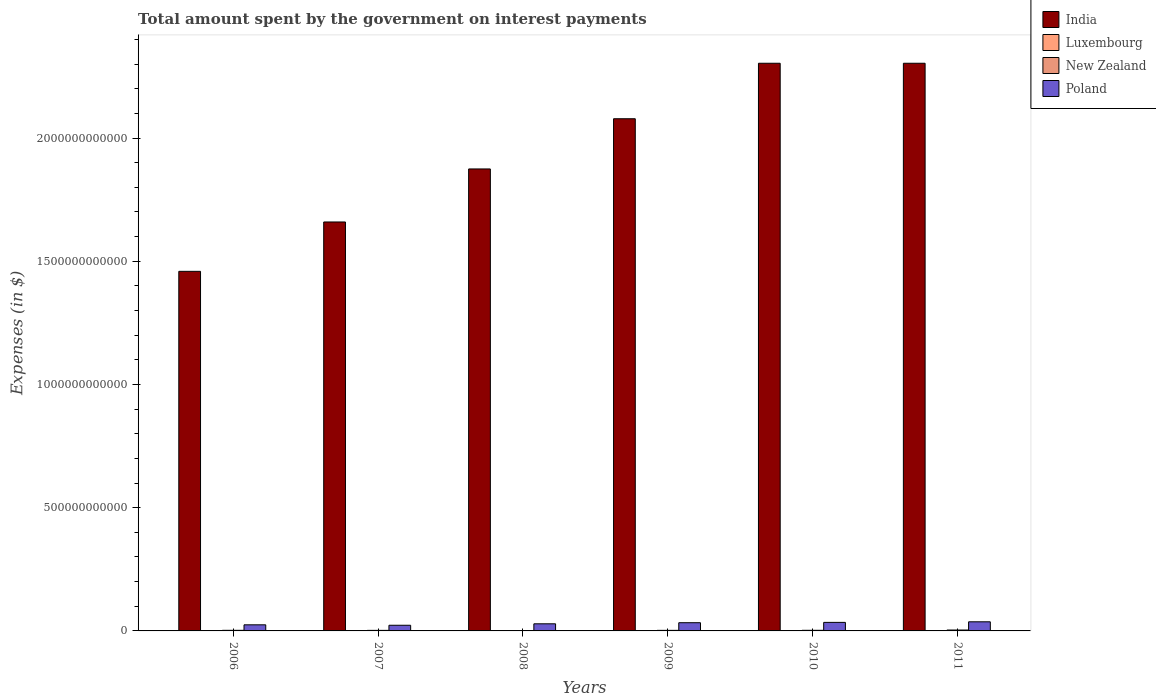How many groups of bars are there?
Provide a short and direct response. 6. How many bars are there on the 5th tick from the left?
Your response must be concise. 4. How many bars are there on the 1st tick from the right?
Your answer should be compact. 4. What is the amount spent on interest payments by the government in India in 2007?
Give a very brief answer. 1.66e+12. Across all years, what is the maximum amount spent on interest payments by the government in Poland?
Offer a terse response. 3.70e+1. Across all years, what is the minimum amount spent on interest payments by the government in India?
Your answer should be very brief. 1.46e+12. In which year was the amount spent on interest payments by the government in Poland maximum?
Keep it short and to the point. 2011. What is the total amount spent on interest payments by the government in Poland in the graph?
Offer a terse response. 1.82e+11. What is the difference between the amount spent on interest payments by the government in Poland in 2006 and that in 2009?
Your response must be concise. -8.59e+09. What is the difference between the amount spent on interest payments by the government in India in 2011 and the amount spent on interest payments by the government in New Zealand in 2007?
Your answer should be very brief. 2.30e+12. What is the average amount spent on interest payments by the government in Poland per year?
Offer a terse response. 3.03e+1. In the year 2011, what is the difference between the amount spent on interest payments by the government in Luxembourg and amount spent on interest payments by the government in India?
Keep it short and to the point. -2.30e+12. In how many years, is the amount spent on interest payments by the government in India greater than 2200000000000 $?
Your response must be concise. 2. What is the ratio of the amount spent on interest payments by the government in Luxembourg in 2009 to that in 2011?
Offer a terse response. 0.65. Is the amount spent on interest payments by the government in Poland in 2010 less than that in 2011?
Ensure brevity in your answer.  Yes. What is the difference between the highest and the lowest amount spent on interest payments by the government in Luxembourg?
Your response must be concise. 1.47e+08. In how many years, is the amount spent on interest payments by the government in Poland greater than the average amount spent on interest payments by the government in Poland taken over all years?
Keep it short and to the point. 3. Is it the case that in every year, the sum of the amount spent on interest payments by the government in Luxembourg and amount spent on interest payments by the government in Poland is greater than the sum of amount spent on interest payments by the government in New Zealand and amount spent on interest payments by the government in India?
Provide a short and direct response. No. What does the 2nd bar from the left in 2006 represents?
Offer a terse response. Luxembourg. What does the 4th bar from the right in 2009 represents?
Your response must be concise. India. Is it the case that in every year, the sum of the amount spent on interest payments by the government in Poland and amount spent on interest payments by the government in Luxembourg is greater than the amount spent on interest payments by the government in India?
Provide a succinct answer. No. How many bars are there?
Your answer should be very brief. 24. Are all the bars in the graph horizontal?
Offer a terse response. No. How many years are there in the graph?
Provide a succinct answer. 6. What is the difference between two consecutive major ticks on the Y-axis?
Your response must be concise. 5.00e+11. Are the values on the major ticks of Y-axis written in scientific E-notation?
Offer a terse response. No. Does the graph contain grids?
Provide a succinct answer. No. How are the legend labels stacked?
Give a very brief answer. Vertical. What is the title of the graph?
Your response must be concise. Total amount spent by the government on interest payments. What is the label or title of the Y-axis?
Your response must be concise. Expenses (in $). What is the Expenses (in $) of India in 2006?
Keep it short and to the point. 1.46e+12. What is the Expenses (in $) of Luxembourg in 2006?
Give a very brief answer. 3.89e+07. What is the Expenses (in $) of New Zealand in 2006?
Ensure brevity in your answer.  2.46e+09. What is the Expenses (in $) of Poland in 2006?
Keep it short and to the point. 2.47e+1. What is the Expenses (in $) in India in 2007?
Provide a succinct answer. 1.66e+12. What is the Expenses (in $) of Luxembourg in 2007?
Provide a short and direct response. 5.74e+07. What is the Expenses (in $) of New Zealand in 2007?
Give a very brief answer. 2.25e+09. What is the Expenses (in $) in Poland in 2007?
Your response must be concise. 2.30e+1. What is the Expenses (in $) of India in 2008?
Provide a short and direct response. 1.87e+12. What is the Expenses (in $) in Luxembourg in 2008?
Your answer should be compact. 8.89e+07. What is the Expenses (in $) of New Zealand in 2008?
Your response must be concise. 1.34e+09. What is the Expenses (in $) of Poland in 2008?
Offer a terse response. 2.89e+1. What is the Expenses (in $) of India in 2009?
Give a very brief answer. 2.08e+12. What is the Expenses (in $) of Luxembourg in 2009?
Offer a very short reply. 1.20e+08. What is the Expenses (in $) in New Zealand in 2009?
Give a very brief answer. 2.30e+09. What is the Expenses (in $) of Poland in 2009?
Ensure brevity in your answer.  3.33e+1. What is the Expenses (in $) of India in 2010?
Your answer should be very brief. 2.30e+12. What is the Expenses (in $) of Luxembourg in 2010?
Provide a short and direct response. 1.51e+08. What is the Expenses (in $) of New Zealand in 2010?
Make the answer very short. 2.52e+09. What is the Expenses (in $) in Poland in 2010?
Your answer should be compact. 3.47e+1. What is the Expenses (in $) of India in 2011?
Give a very brief answer. 2.30e+12. What is the Expenses (in $) in Luxembourg in 2011?
Your answer should be very brief. 1.86e+08. What is the Expenses (in $) in New Zealand in 2011?
Ensure brevity in your answer.  3.66e+09. What is the Expenses (in $) of Poland in 2011?
Your response must be concise. 3.70e+1. Across all years, what is the maximum Expenses (in $) of India?
Keep it short and to the point. 2.30e+12. Across all years, what is the maximum Expenses (in $) in Luxembourg?
Give a very brief answer. 1.86e+08. Across all years, what is the maximum Expenses (in $) in New Zealand?
Provide a succinct answer. 3.66e+09. Across all years, what is the maximum Expenses (in $) in Poland?
Offer a very short reply. 3.70e+1. Across all years, what is the minimum Expenses (in $) in India?
Provide a short and direct response. 1.46e+12. Across all years, what is the minimum Expenses (in $) of Luxembourg?
Provide a short and direct response. 3.89e+07. Across all years, what is the minimum Expenses (in $) in New Zealand?
Offer a very short reply. 1.34e+09. Across all years, what is the minimum Expenses (in $) of Poland?
Ensure brevity in your answer.  2.30e+1. What is the total Expenses (in $) of India in the graph?
Give a very brief answer. 1.17e+13. What is the total Expenses (in $) of Luxembourg in the graph?
Ensure brevity in your answer.  6.42e+08. What is the total Expenses (in $) in New Zealand in the graph?
Give a very brief answer. 1.45e+1. What is the total Expenses (in $) in Poland in the graph?
Ensure brevity in your answer.  1.82e+11. What is the difference between the Expenses (in $) in India in 2006 and that in 2007?
Give a very brief answer. -2.00e+11. What is the difference between the Expenses (in $) in Luxembourg in 2006 and that in 2007?
Provide a succinct answer. -1.85e+07. What is the difference between the Expenses (in $) in New Zealand in 2006 and that in 2007?
Your answer should be very brief. 2.02e+08. What is the difference between the Expenses (in $) in Poland in 2006 and that in 2007?
Offer a terse response. 1.73e+09. What is the difference between the Expenses (in $) in India in 2006 and that in 2008?
Your answer should be compact. -4.16e+11. What is the difference between the Expenses (in $) in Luxembourg in 2006 and that in 2008?
Your answer should be very brief. -4.99e+07. What is the difference between the Expenses (in $) in New Zealand in 2006 and that in 2008?
Ensure brevity in your answer.  1.12e+09. What is the difference between the Expenses (in $) in Poland in 2006 and that in 2008?
Provide a succinct answer. -4.13e+09. What is the difference between the Expenses (in $) in India in 2006 and that in 2009?
Make the answer very short. -6.19e+11. What is the difference between the Expenses (in $) of Luxembourg in 2006 and that in 2009?
Ensure brevity in your answer.  -8.14e+07. What is the difference between the Expenses (in $) of New Zealand in 2006 and that in 2009?
Your response must be concise. 1.59e+08. What is the difference between the Expenses (in $) in Poland in 2006 and that in 2009?
Provide a succinct answer. -8.59e+09. What is the difference between the Expenses (in $) of India in 2006 and that in 2010?
Your answer should be very brief. -8.44e+11. What is the difference between the Expenses (in $) in Luxembourg in 2006 and that in 2010?
Provide a succinct answer. -1.12e+08. What is the difference between the Expenses (in $) in New Zealand in 2006 and that in 2010?
Provide a succinct answer. -6.60e+07. What is the difference between the Expenses (in $) in Poland in 2006 and that in 2010?
Give a very brief answer. -9.93e+09. What is the difference between the Expenses (in $) in India in 2006 and that in 2011?
Provide a short and direct response. -8.44e+11. What is the difference between the Expenses (in $) of Luxembourg in 2006 and that in 2011?
Give a very brief answer. -1.47e+08. What is the difference between the Expenses (in $) of New Zealand in 2006 and that in 2011?
Provide a succinct answer. -1.20e+09. What is the difference between the Expenses (in $) in Poland in 2006 and that in 2011?
Give a very brief answer. -1.22e+1. What is the difference between the Expenses (in $) of India in 2007 and that in 2008?
Keep it short and to the point. -2.15e+11. What is the difference between the Expenses (in $) in Luxembourg in 2007 and that in 2008?
Provide a short and direct response. -3.15e+07. What is the difference between the Expenses (in $) in New Zealand in 2007 and that in 2008?
Your answer should be compact. 9.17e+08. What is the difference between the Expenses (in $) of Poland in 2007 and that in 2008?
Offer a very short reply. -5.86e+09. What is the difference between the Expenses (in $) in India in 2007 and that in 2009?
Offer a terse response. -4.19e+11. What is the difference between the Expenses (in $) in Luxembourg in 2007 and that in 2009?
Your response must be concise. -6.29e+07. What is the difference between the Expenses (in $) in New Zealand in 2007 and that in 2009?
Provide a succinct answer. -4.27e+07. What is the difference between the Expenses (in $) of Poland in 2007 and that in 2009?
Offer a very short reply. -1.03e+1. What is the difference between the Expenses (in $) in India in 2007 and that in 2010?
Ensure brevity in your answer.  -6.44e+11. What is the difference between the Expenses (in $) of Luxembourg in 2007 and that in 2010?
Ensure brevity in your answer.  -9.34e+07. What is the difference between the Expenses (in $) of New Zealand in 2007 and that in 2010?
Keep it short and to the point. -2.68e+08. What is the difference between the Expenses (in $) in Poland in 2007 and that in 2010?
Your response must be concise. -1.17e+1. What is the difference between the Expenses (in $) of India in 2007 and that in 2011?
Your answer should be compact. -6.44e+11. What is the difference between the Expenses (in $) of Luxembourg in 2007 and that in 2011?
Your answer should be very brief. -1.28e+08. What is the difference between the Expenses (in $) of New Zealand in 2007 and that in 2011?
Keep it short and to the point. -1.41e+09. What is the difference between the Expenses (in $) of Poland in 2007 and that in 2011?
Your answer should be compact. -1.40e+1. What is the difference between the Expenses (in $) of India in 2008 and that in 2009?
Provide a succinct answer. -2.04e+11. What is the difference between the Expenses (in $) in Luxembourg in 2008 and that in 2009?
Offer a very short reply. -3.14e+07. What is the difference between the Expenses (in $) in New Zealand in 2008 and that in 2009?
Ensure brevity in your answer.  -9.60e+08. What is the difference between the Expenses (in $) in Poland in 2008 and that in 2009?
Offer a terse response. -4.46e+09. What is the difference between the Expenses (in $) of India in 2008 and that in 2010?
Ensure brevity in your answer.  -4.29e+11. What is the difference between the Expenses (in $) in Luxembourg in 2008 and that in 2010?
Offer a very short reply. -6.20e+07. What is the difference between the Expenses (in $) in New Zealand in 2008 and that in 2010?
Give a very brief answer. -1.18e+09. What is the difference between the Expenses (in $) in Poland in 2008 and that in 2010?
Your answer should be very brief. -5.80e+09. What is the difference between the Expenses (in $) of India in 2008 and that in 2011?
Ensure brevity in your answer.  -4.29e+11. What is the difference between the Expenses (in $) in Luxembourg in 2008 and that in 2011?
Offer a very short reply. -9.67e+07. What is the difference between the Expenses (in $) in New Zealand in 2008 and that in 2011?
Your answer should be very brief. -2.32e+09. What is the difference between the Expenses (in $) in Poland in 2008 and that in 2011?
Give a very brief answer. -8.12e+09. What is the difference between the Expenses (in $) in India in 2009 and that in 2010?
Your response must be concise. -2.25e+11. What is the difference between the Expenses (in $) in Luxembourg in 2009 and that in 2010?
Offer a very short reply. -3.06e+07. What is the difference between the Expenses (in $) of New Zealand in 2009 and that in 2010?
Make the answer very short. -2.25e+08. What is the difference between the Expenses (in $) in Poland in 2009 and that in 2010?
Keep it short and to the point. -1.34e+09. What is the difference between the Expenses (in $) in India in 2009 and that in 2011?
Give a very brief answer. -2.25e+11. What is the difference between the Expenses (in $) in Luxembourg in 2009 and that in 2011?
Your answer should be compact. -6.53e+07. What is the difference between the Expenses (in $) in New Zealand in 2009 and that in 2011?
Make the answer very short. -1.36e+09. What is the difference between the Expenses (in $) of Poland in 2009 and that in 2011?
Provide a short and direct response. -3.66e+09. What is the difference between the Expenses (in $) of India in 2010 and that in 2011?
Provide a succinct answer. 0. What is the difference between the Expenses (in $) in Luxembourg in 2010 and that in 2011?
Ensure brevity in your answer.  -3.47e+07. What is the difference between the Expenses (in $) of New Zealand in 2010 and that in 2011?
Your response must be concise. -1.14e+09. What is the difference between the Expenses (in $) of Poland in 2010 and that in 2011?
Provide a short and direct response. -2.32e+09. What is the difference between the Expenses (in $) in India in 2006 and the Expenses (in $) in Luxembourg in 2007?
Offer a terse response. 1.46e+12. What is the difference between the Expenses (in $) of India in 2006 and the Expenses (in $) of New Zealand in 2007?
Give a very brief answer. 1.46e+12. What is the difference between the Expenses (in $) of India in 2006 and the Expenses (in $) of Poland in 2007?
Make the answer very short. 1.44e+12. What is the difference between the Expenses (in $) of Luxembourg in 2006 and the Expenses (in $) of New Zealand in 2007?
Keep it short and to the point. -2.22e+09. What is the difference between the Expenses (in $) in Luxembourg in 2006 and the Expenses (in $) in Poland in 2007?
Make the answer very short. -2.30e+1. What is the difference between the Expenses (in $) in New Zealand in 2006 and the Expenses (in $) in Poland in 2007?
Your answer should be very brief. -2.05e+1. What is the difference between the Expenses (in $) of India in 2006 and the Expenses (in $) of Luxembourg in 2008?
Ensure brevity in your answer.  1.46e+12. What is the difference between the Expenses (in $) in India in 2006 and the Expenses (in $) in New Zealand in 2008?
Provide a succinct answer. 1.46e+12. What is the difference between the Expenses (in $) in India in 2006 and the Expenses (in $) in Poland in 2008?
Your answer should be compact. 1.43e+12. What is the difference between the Expenses (in $) of Luxembourg in 2006 and the Expenses (in $) of New Zealand in 2008?
Make the answer very short. -1.30e+09. What is the difference between the Expenses (in $) of Luxembourg in 2006 and the Expenses (in $) of Poland in 2008?
Your response must be concise. -2.88e+1. What is the difference between the Expenses (in $) in New Zealand in 2006 and the Expenses (in $) in Poland in 2008?
Offer a terse response. -2.64e+1. What is the difference between the Expenses (in $) of India in 2006 and the Expenses (in $) of Luxembourg in 2009?
Offer a very short reply. 1.46e+12. What is the difference between the Expenses (in $) in India in 2006 and the Expenses (in $) in New Zealand in 2009?
Provide a succinct answer. 1.46e+12. What is the difference between the Expenses (in $) in India in 2006 and the Expenses (in $) in Poland in 2009?
Ensure brevity in your answer.  1.43e+12. What is the difference between the Expenses (in $) of Luxembourg in 2006 and the Expenses (in $) of New Zealand in 2009?
Your answer should be compact. -2.26e+09. What is the difference between the Expenses (in $) of Luxembourg in 2006 and the Expenses (in $) of Poland in 2009?
Offer a very short reply. -3.33e+1. What is the difference between the Expenses (in $) in New Zealand in 2006 and the Expenses (in $) in Poland in 2009?
Offer a terse response. -3.09e+1. What is the difference between the Expenses (in $) in India in 2006 and the Expenses (in $) in Luxembourg in 2010?
Give a very brief answer. 1.46e+12. What is the difference between the Expenses (in $) in India in 2006 and the Expenses (in $) in New Zealand in 2010?
Provide a succinct answer. 1.46e+12. What is the difference between the Expenses (in $) of India in 2006 and the Expenses (in $) of Poland in 2010?
Give a very brief answer. 1.42e+12. What is the difference between the Expenses (in $) of Luxembourg in 2006 and the Expenses (in $) of New Zealand in 2010?
Provide a succinct answer. -2.48e+09. What is the difference between the Expenses (in $) in Luxembourg in 2006 and the Expenses (in $) in Poland in 2010?
Your answer should be very brief. -3.46e+1. What is the difference between the Expenses (in $) of New Zealand in 2006 and the Expenses (in $) of Poland in 2010?
Offer a terse response. -3.22e+1. What is the difference between the Expenses (in $) in India in 2006 and the Expenses (in $) in Luxembourg in 2011?
Your answer should be compact. 1.46e+12. What is the difference between the Expenses (in $) in India in 2006 and the Expenses (in $) in New Zealand in 2011?
Your answer should be very brief. 1.46e+12. What is the difference between the Expenses (in $) of India in 2006 and the Expenses (in $) of Poland in 2011?
Ensure brevity in your answer.  1.42e+12. What is the difference between the Expenses (in $) of Luxembourg in 2006 and the Expenses (in $) of New Zealand in 2011?
Offer a terse response. -3.62e+09. What is the difference between the Expenses (in $) in Luxembourg in 2006 and the Expenses (in $) in Poland in 2011?
Your answer should be compact. -3.69e+1. What is the difference between the Expenses (in $) in New Zealand in 2006 and the Expenses (in $) in Poland in 2011?
Give a very brief answer. -3.45e+1. What is the difference between the Expenses (in $) in India in 2007 and the Expenses (in $) in Luxembourg in 2008?
Your answer should be compact. 1.66e+12. What is the difference between the Expenses (in $) in India in 2007 and the Expenses (in $) in New Zealand in 2008?
Offer a very short reply. 1.66e+12. What is the difference between the Expenses (in $) in India in 2007 and the Expenses (in $) in Poland in 2008?
Keep it short and to the point. 1.63e+12. What is the difference between the Expenses (in $) of Luxembourg in 2007 and the Expenses (in $) of New Zealand in 2008?
Offer a very short reply. -1.28e+09. What is the difference between the Expenses (in $) in Luxembourg in 2007 and the Expenses (in $) in Poland in 2008?
Keep it short and to the point. -2.88e+1. What is the difference between the Expenses (in $) of New Zealand in 2007 and the Expenses (in $) of Poland in 2008?
Keep it short and to the point. -2.66e+1. What is the difference between the Expenses (in $) in India in 2007 and the Expenses (in $) in Luxembourg in 2009?
Your answer should be compact. 1.66e+12. What is the difference between the Expenses (in $) of India in 2007 and the Expenses (in $) of New Zealand in 2009?
Make the answer very short. 1.66e+12. What is the difference between the Expenses (in $) of India in 2007 and the Expenses (in $) of Poland in 2009?
Provide a short and direct response. 1.63e+12. What is the difference between the Expenses (in $) of Luxembourg in 2007 and the Expenses (in $) of New Zealand in 2009?
Your answer should be compact. -2.24e+09. What is the difference between the Expenses (in $) in Luxembourg in 2007 and the Expenses (in $) in Poland in 2009?
Make the answer very short. -3.33e+1. What is the difference between the Expenses (in $) of New Zealand in 2007 and the Expenses (in $) of Poland in 2009?
Your answer should be compact. -3.11e+1. What is the difference between the Expenses (in $) of India in 2007 and the Expenses (in $) of Luxembourg in 2010?
Provide a short and direct response. 1.66e+12. What is the difference between the Expenses (in $) of India in 2007 and the Expenses (in $) of New Zealand in 2010?
Give a very brief answer. 1.66e+12. What is the difference between the Expenses (in $) of India in 2007 and the Expenses (in $) of Poland in 2010?
Offer a very short reply. 1.62e+12. What is the difference between the Expenses (in $) of Luxembourg in 2007 and the Expenses (in $) of New Zealand in 2010?
Your answer should be very brief. -2.46e+09. What is the difference between the Expenses (in $) of Luxembourg in 2007 and the Expenses (in $) of Poland in 2010?
Provide a short and direct response. -3.46e+1. What is the difference between the Expenses (in $) of New Zealand in 2007 and the Expenses (in $) of Poland in 2010?
Offer a terse response. -3.24e+1. What is the difference between the Expenses (in $) of India in 2007 and the Expenses (in $) of Luxembourg in 2011?
Provide a succinct answer. 1.66e+12. What is the difference between the Expenses (in $) in India in 2007 and the Expenses (in $) in New Zealand in 2011?
Give a very brief answer. 1.66e+12. What is the difference between the Expenses (in $) in India in 2007 and the Expenses (in $) in Poland in 2011?
Your response must be concise. 1.62e+12. What is the difference between the Expenses (in $) of Luxembourg in 2007 and the Expenses (in $) of New Zealand in 2011?
Provide a short and direct response. -3.60e+09. What is the difference between the Expenses (in $) in Luxembourg in 2007 and the Expenses (in $) in Poland in 2011?
Offer a terse response. -3.69e+1. What is the difference between the Expenses (in $) in New Zealand in 2007 and the Expenses (in $) in Poland in 2011?
Offer a terse response. -3.47e+1. What is the difference between the Expenses (in $) in India in 2008 and the Expenses (in $) in Luxembourg in 2009?
Keep it short and to the point. 1.87e+12. What is the difference between the Expenses (in $) of India in 2008 and the Expenses (in $) of New Zealand in 2009?
Your answer should be very brief. 1.87e+12. What is the difference between the Expenses (in $) in India in 2008 and the Expenses (in $) in Poland in 2009?
Give a very brief answer. 1.84e+12. What is the difference between the Expenses (in $) of Luxembourg in 2008 and the Expenses (in $) of New Zealand in 2009?
Keep it short and to the point. -2.21e+09. What is the difference between the Expenses (in $) in Luxembourg in 2008 and the Expenses (in $) in Poland in 2009?
Your answer should be compact. -3.32e+1. What is the difference between the Expenses (in $) of New Zealand in 2008 and the Expenses (in $) of Poland in 2009?
Make the answer very short. -3.20e+1. What is the difference between the Expenses (in $) in India in 2008 and the Expenses (in $) in Luxembourg in 2010?
Your answer should be compact. 1.87e+12. What is the difference between the Expenses (in $) of India in 2008 and the Expenses (in $) of New Zealand in 2010?
Your answer should be very brief. 1.87e+12. What is the difference between the Expenses (in $) of India in 2008 and the Expenses (in $) of Poland in 2010?
Offer a very short reply. 1.84e+12. What is the difference between the Expenses (in $) of Luxembourg in 2008 and the Expenses (in $) of New Zealand in 2010?
Your answer should be very brief. -2.43e+09. What is the difference between the Expenses (in $) of Luxembourg in 2008 and the Expenses (in $) of Poland in 2010?
Your answer should be compact. -3.46e+1. What is the difference between the Expenses (in $) of New Zealand in 2008 and the Expenses (in $) of Poland in 2010?
Your answer should be compact. -3.33e+1. What is the difference between the Expenses (in $) of India in 2008 and the Expenses (in $) of Luxembourg in 2011?
Provide a succinct answer. 1.87e+12. What is the difference between the Expenses (in $) of India in 2008 and the Expenses (in $) of New Zealand in 2011?
Your response must be concise. 1.87e+12. What is the difference between the Expenses (in $) in India in 2008 and the Expenses (in $) in Poland in 2011?
Provide a succinct answer. 1.84e+12. What is the difference between the Expenses (in $) in Luxembourg in 2008 and the Expenses (in $) in New Zealand in 2011?
Offer a terse response. -3.57e+09. What is the difference between the Expenses (in $) of Luxembourg in 2008 and the Expenses (in $) of Poland in 2011?
Provide a short and direct response. -3.69e+1. What is the difference between the Expenses (in $) in New Zealand in 2008 and the Expenses (in $) in Poland in 2011?
Provide a succinct answer. -3.56e+1. What is the difference between the Expenses (in $) in India in 2009 and the Expenses (in $) in Luxembourg in 2010?
Your answer should be compact. 2.08e+12. What is the difference between the Expenses (in $) in India in 2009 and the Expenses (in $) in New Zealand in 2010?
Offer a terse response. 2.08e+12. What is the difference between the Expenses (in $) in India in 2009 and the Expenses (in $) in Poland in 2010?
Provide a succinct answer. 2.04e+12. What is the difference between the Expenses (in $) of Luxembourg in 2009 and the Expenses (in $) of New Zealand in 2010?
Make the answer very short. -2.40e+09. What is the difference between the Expenses (in $) in Luxembourg in 2009 and the Expenses (in $) in Poland in 2010?
Provide a succinct answer. -3.45e+1. What is the difference between the Expenses (in $) of New Zealand in 2009 and the Expenses (in $) of Poland in 2010?
Your answer should be very brief. -3.24e+1. What is the difference between the Expenses (in $) of India in 2009 and the Expenses (in $) of Luxembourg in 2011?
Give a very brief answer. 2.08e+12. What is the difference between the Expenses (in $) of India in 2009 and the Expenses (in $) of New Zealand in 2011?
Provide a short and direct response. 2.07e+12. What is the difference between the Expenses (in $) of India in 2009 and the Expenses (in $) of Poland in 2011?
Provide a short and direct response. 2.04e+12. What is the difference between the Expenses (in $) of Luxembourg in 2009 and the Expenses (in $) of New Zealand in 2011?
Provide a succinct answer. -3.54e+09. What is the difference between the Expenses (in $) in Luxembourg in 2009 and the Expenses (in $) in Poland in 2011?
Your answer should be compact. -3.69e+1. What is the difference between the Expenses (in $) in New Zealand in 2009 and the Expenses (in $) in Poland in 2011?
Provide a short and direct response. -3.47e+1. What is the difference between the Expenses (in $) in India in 2010 and the Expenses (in $) in Luxembourg in 2011?
Your response must be concise. 2.30e+12. What is the difference between the Expenses (in $) in India in 2010 and the Expenses (in $) in New Zealand in 2011?
Keep it short and to the point. 2.30e+12. What is the difference between the Expenses (in $) in India in 2010 and the Expenses (in $) in Poland in 2011?
Provide a succinct answer. 2.27e+12. What is the difference between the Expenses (in $) in Luxembourg in 2010 and the Expenses (in $) in New Zealand in 2011?
Provide a short and direct response. -3.51e+09. What is the difference between the Expenses (in $) in Luxembourg in 2010 and the Expenses (in $) in Poland in 2011?
Your response must be concise. -3.68e+1. What is the difference between the Expenses (in $) in New Zealand in 2010 and the Expenses (in $) in Poland in 2011?
Your answer should be very brief. -3.45e+1. What is the average Expenses (in $) in India per year?
Offer a terse response. 1.95e+12. What is the average Expenses (in $) of Luxembourg per year?
Give a very brief answer. 1.07e+08. What is the average Expenses (in $) in New Zealand per year?
Make the answer very short. 2.42e+09. What is the average Expenses (in $) of Poland per year?
Provide a short and direct response. 3.03e+1. In the year 2006, what is the difference between the Expenses (in $) in India and Expenses (in $) in Luxembourg?
Your response must be concise. 1.46e+12. In the year 2006, what is the difference between the Expenses (in $) in India and Expenses (in $) in New Zealand?
Provide a short and direct response. 1.46e+12. In the year 2006, what is the difference between the Expenses (in $) in India and Expenses (in $) in Poland?
Offer a very short reply. 1.43e+12. In the year 2006, what is the difference between the Expenses (in $) in Luxembourg and Expenses (in $) in New Zealand?
Keep it short and to the point. -2.42e+09. In the year 2006, what is the difference between the Expenses (in $) of Luxembourg and Expenses (in $) of Poland?
Give a very brief answer. -2.47e+1. In the year 2006, what is the difference between the Expenses (in $) in New Zealand and Expenses (in $) in Poland?
Give a very brief answer. -2.23e+1. In the year 2007, what is the difference between the Expenses (in $) in India and Expenses (in $) in Luxembourg?
Your response must be concise. 1.66e+12. In the year 2007, what is the difference between the Expenses (in $) in India and Expenses (in $) in New Zealand?
Offer a very short reply. 1.66e+12. In the year 2007, what is the difference between the Expenses (in $) in India and Expenses (in $) in Poland?
Offer a terse response. 1.64e+12. In the year 2007, what is the difference between the Expenses (in $) in Luxembourg and Expenses (in $) in New Zealand?
Offer a very short reply. -2.20e+09. In the year 2007, what is the difference between the Expenses (in $) in Luxembourg and Expenses (in $) in Poland?
Make the answer very short. -2.29e+1. In the year 2007, what is the difference between the Expenses (in $) in New Zealand and Expenses (in $) in Poland?
Give a very brief answer. -2.08e+1. In the year 2008, what is the difference between the Expenses (in $) of India and Expenses (in $) of Luxembourg?
Provide a short and direct response. 1.87e+12. In the year 2008, what is the difference between the Expenses (in $) in India and Expenses (in $) in New Zealand?
Provide a succinct answer. 1.87e+12. In the year 2008, what is the difference between the Expenses (in $) in India and Expenses (in $) in Poland?
Offer a terse response. 1.85e+12. In the year 2008, what is the difference between the Expenses (in $) of Luxembourg and Expenses (in $) of New Zealand?
Provide a succinct answer. -1.25e+09. In the year 2008, what is the difference between the Expenses (in $) of Luxembourg and Expenses (in $) of Poland?
Offer a terse response. -2.88e+1. In the year 2008, what is the difference between the Expenses (in $) in New Zealand and Expenses (in $) in Poland?
Keep it short and to the point. -2.75e+1. In the year 2009, what is the difference between the Expenses (in $) in India and Expenses (in $) in Luxembourg?
Make the answer very short. 2.08e+12. In the year 2009, what is the difference between the Expenses (in $) in India and Expenses (in $) in New Zealand?
Offer a very short reply. 2.08e+12. In the year 2009, what is the difference between the Expenses (in $) of India and Expenses (in $) of Poland?
Give a very brief answer. 2.05e+12. In the year 2009, what is the difference between the Expenses (in $) in Luxembourg and Expenses (in $) in New Zealand?
Make the answer very short. -2.18e+09. In the year 2009, what is the difference between the Expenses (in $) of Luxembourg and Expenses (in $) of Poland?
Your answer should be very brief. -3.32e+1. In the year 2009, what is the difference between the Expenses (in $) in New Zealand and Expenses (in $) in Poland?
Make the answer very short. -3.10e+1. In the year 2010, what is the difference between the Expenses (in $) of India and Expenses (in $) of Luxembourg?
Make the answer very short. 2.30e+12. In the year 2010, what is the difference between the Expenses (in $) of India and Expenses (in $) of New Zealand?
Provide a short and direct response. 2.30e+12. In the year 2010, what is the difference between the Expenses (in $) of India and Expenses (in $) of Poland?
Provide a short and direct response. 2.27e+12. In the year 2010, what is the difference between the Expenses (in $) in Luxembourg and Expenses (in $) in New Zealand?
Your answer should be very brief. -2.37e+09. In the year 2010, what is the difference between the Expenses (in $) of Luxembourg and Expenses (in $) of Poland?
Keep it short and to the point. -3.45e+1. In the year 2010, what is the difference between the Expenses (in $) of New Zealand and Expenses (in $) of Poland?
Keep it short and to the point. -3.21e+1. In the year 2011, what is the difference between the Expenses (in $) in India and Expenses (in $) in Luxembourg?
Provide a succinct answer. 2.30e+12. In the year 2011, what is the difference between the Expenses (in $) of India and Expenses (in $) of New Zealand?
Ensure brevity in your answer.  2.30e+12. In the year 2011, what is the difference between the Expenses (in $) of India and Expenses (in $) of Poland?
Offer a very short reply. 2.27e+12. In the year 2011, what is the difference between the Expenses (in $) of Luxembourg and Expenses (in $) of New Zealand?
Your answer should be compact. -3.47e+09. In the year 2011, what is the difference between the Expenses (in $) of Luxembourg and Expenses (in $) of Poland?
Provide a short and direct response. -3.68e+1. In the year 2011, what is the difference between the Expenses (in $) of New Zealand and Expenses (in $) of Poland?
Make the answer very short. -3.33e+1. What is the ratio of the Expenses (in $) of India in 2006 to that in 2007?
Offer a very short reply. 0.88. What is the ratio of the Expenses (in $) of Luxembourg in 2006 to that in 2007?
Keep it short and to the point. 0.68. What is the ratio of the Expenses (in $) of New Zealand in 2006 to that in 2007?
Ensure brevity in your answer.  1.09. What is the ratio of the Expenses (in $) of Poland in 2006 to that in 2007?
Offer a very short reply. 1.08. What is the ratio of the Expenses (in $) in India in 2006 to that in 2008?
Your answer should be compact. 0.78. What is the ratio of the Expenses (in $) in Luxembourg in 2006 to that in 2008?
Make the answer very short. 0.44. What is the ratio of the Expenses (in $) of New Zealand in 2006 to that in 2008?
Give a very brief answer. 1.84. What is the ratio of the Expenses (in $) of Poland in 2006 to that in 2008?
Provide a short and direct response. 0.86. What is the ratio of the Expenses (in $) in India in 2006 to that in 2009?
Your answer should be very brief. 0.7. What is the ratio of the Expenses (in $) of Luxembourg in 2006 to that in 2009?
Provide a succinct answer. 0.32. What is the ratio of the Expenses (in $) of New Zealand in 2006 to that in 2009?
Ensure brevity in your answer.  1.07. What is the ratio of the Expenses (in $) in Poland in 2006 to that in 2009?
Provide a short and direct response. 0.74. What is the ratio of the Expenses (in $) in India in 2006 to that in 2010?
Keep it short and to the point. 0.63. What is the ratio of the Expenses (in $) in Luxembourg in 2006 to that in 2010?
Keep it short and to the point. 0.26. What is the ratio of the Expenses (in $) of New Zealand in 2006 to that in 2010?
Keep it short and to the point. 0.97. What is the ratio of the Expenses (in $) in Poland in 2006 to that in 2010?
Offer a terse response. 0.71. What is the ratio of the Expenses (in $) in India in 2006 to that in 2011?
Give a very brief answer. 0.63. What is the ratio of the Expenses (in $) in Luxembourg in 2006 to that in 2011?
Provide a succinct answer. 0.21. What is the ratio of the Expenses (in $) of New Zealand in 2006 to that in 2011?
Keep it short and to the point. 0.67. What is the ratio of the Expenses (in $) in Poland in 2006 to that in 2011?
Give a very brief answer. 0.67. What is the ratio of the Expenses (in $) of India in 2007 to that in 2008?
Your answer should be compact. 0.89. What is the ratio of the Expenses (in $) in Luxembourg in 2007 to that in 2008?
Your response must be concise. 0.65. What is the ratio of the Expenses (in $) in New Zealand in 2007 to that in 2008?
Your answer should be compact. 1.69. What is the ratio of the Expenses (in $) in Poland in 2007 to that in 2008?
Your response must be concise. 0.8. What is the ratio of the Expenses (in $) of India in 2007 to that in 2009?
Ensure brevity in your answer.  0.8. What is the ratio of the Expenses (in $) in Luxembourg in 2007 to that in 2009?
Provide a succinct answer. 0.48. What is the ratio of the Expenses (in $) of New Zealand in 2007 to that in 2009?
Your answer should be compact. 0.98. What is the ratio of the Expenses (in $) in Poland in 2007 to that in 2009?
Provide a succinct answer. 0.69. What is the ratio of the Expenses (in $) in India in 2007 to that in 2010?
Give a very brief answer. 0.72. What is the ratio of the Expenses (in $) in Luxembourg in 2007 to that in 2010?
Provide a short and direct response. 0.38. What is the ratio of the Expenses (in $) in New Zealand in 2007 to that in 2010?
Your response must be concise. 0.89. What is the ratio of the Expenses (in $) in Poland in 2007 to that in 2010?
Offer a terse response. 0.66. What is the ratio of the Expenses (in $) in India in 2007 to that in 2011?
Give a very brief answer. 0.72. What is the ratio of the Expenses (in $) in Luxembourg in 2007 to that in 2011?
Provide a short and direct response. 0.31. What is the ratio of the Expenses (in $) of New Zealand in 2007 to that in 2011?
Make the answer very short. 0.62. What is the ratio of the Expenses (in $) of Poland in 2007 to that in 2011?
Provide a short and direct response. 0.62. What is the ratio of the Expenses (in $) in India in 2008 to that in 2009?
Your answer should be very brief. 0.9. What is the ratio of the Expenses (in $) of Luxembourg in 2008 to that in 2009?
Your answer should be very brief. 0.74. What is the ratio of the Expenses (in $) in New Zealand in 2008 to that in 2009?
Keep it short and to the point. 0.58. What is the ratio of the Expenses (in $) in Poland in 2008 to that in 2009?
Your response must be concise. 0.87. What is the ratio of the Expenses (in $) in India in 2008 to that in 2010?
Offer a very short reply. 0.81. What is the ratio of the Expenses (in $) of Luxembourg in 2008 to that in 2010?
Ensure brevity in your answer.  0.59. What is the ratio of the Expenses (in $) of New Zealand in 2008 to that in 2010?
Offer a very short reply. 0.53. What is the ratio of the Expenses (in $) in Poland in 2008 to that in 2010?
Offer a very short reply. 0.83. What is the ratio of the Expenses (in $) in India in 2008 to that in 2011?
Provide a succinct answer. 0.81. What is the ratio of the Expenses (in $) of Luxembourg in 2008 to that in 2011?
Your answer should be compact. 0.48. What is the ratio of the Expenses (in $) of New Zealand in 2008 to that in 2011?
Ensure brevity in your answer.  0.37. What is the ratio of the Expenses (in $) in Poland in 2008 to that in 2011?
Provide a succinct answer. 0.78. What is the ratio of the Expenses (in $) of India in 2009 to that in 2010?
Keep it short and to the point. 0.9. What is the ratio of the Expenses (in $) of Luxembourg in 2009 to that in 2010?
Provide a short and direct response. 0.8. What is the ratio of the Expenses (in $) of New Zealand in 2009 to that in 2010?
Your answer should be compact. 0.91. What is the ratio of the Expenses (in $) of Poland in 2009 to that in 2010?
Provide a succinct answer. 0.96. What is the ratio of the Expenses (in $) of India in 2009 to that in 2011?
Give a very brief answer. 0.9. What is the ratio of the Expenses (in $) of Luxembourg in 2009 to that in 2011?
Your answer should be very brief. 0.65. What is the ratio of the Expenses (in $) in New Zealand in 2009 to that in 2011?
Keep it short and to the point. 0.63. What is the ratio of the Expenses (in $) in Poland in 2009 to that in 2011?
Keep it short and to the point. 0.9. What is the ratio of the Expenses (in $) of Luxembourg in 2010 to that in 2011?
Offer a very short reply. 0.81. What is the ratio of the Expenses (in $) in New Zealand in 2010 to that in 2011?
Keep it short and to the point. 0.69. What is the ratio of the Expenses (in $) of Poland in 2010 to that in 2011?
Offer a terse response. 0.94. What is the difference between the highest and the second highest Expenses (in $) of India?
Offer a terse response. 0. What is the difference between the highest and the second highest Expenses (in $) of Luxembourg?
Offer a terse response. 3.47e+07. What is the difference between the highest and the second highest Expenses (in $) in New Zealand?
Offer a very short reply. 1.14e+09. What is the difference between the highest and the second highest Expenses (in $) in Poland?
Make the answer very short. 2.32e+09. What is the difference between the highest and the lowest Expenses (in $) in India?
Provide a succinct answer. 8.44e+11. What is the difference between the highest and the lowest Expenses (in $) in Luxembourg?
Provide a short and direct response. 1.47e+08. What is the difference between the highest and the lowest Expenses (in $) in New Zealand?
Offer a very short reply. 2.32e+09. What is the difference between the highest and the lowest Expenses (in $) of Poland?
Provide a succinct answer. 1.40e+1. 